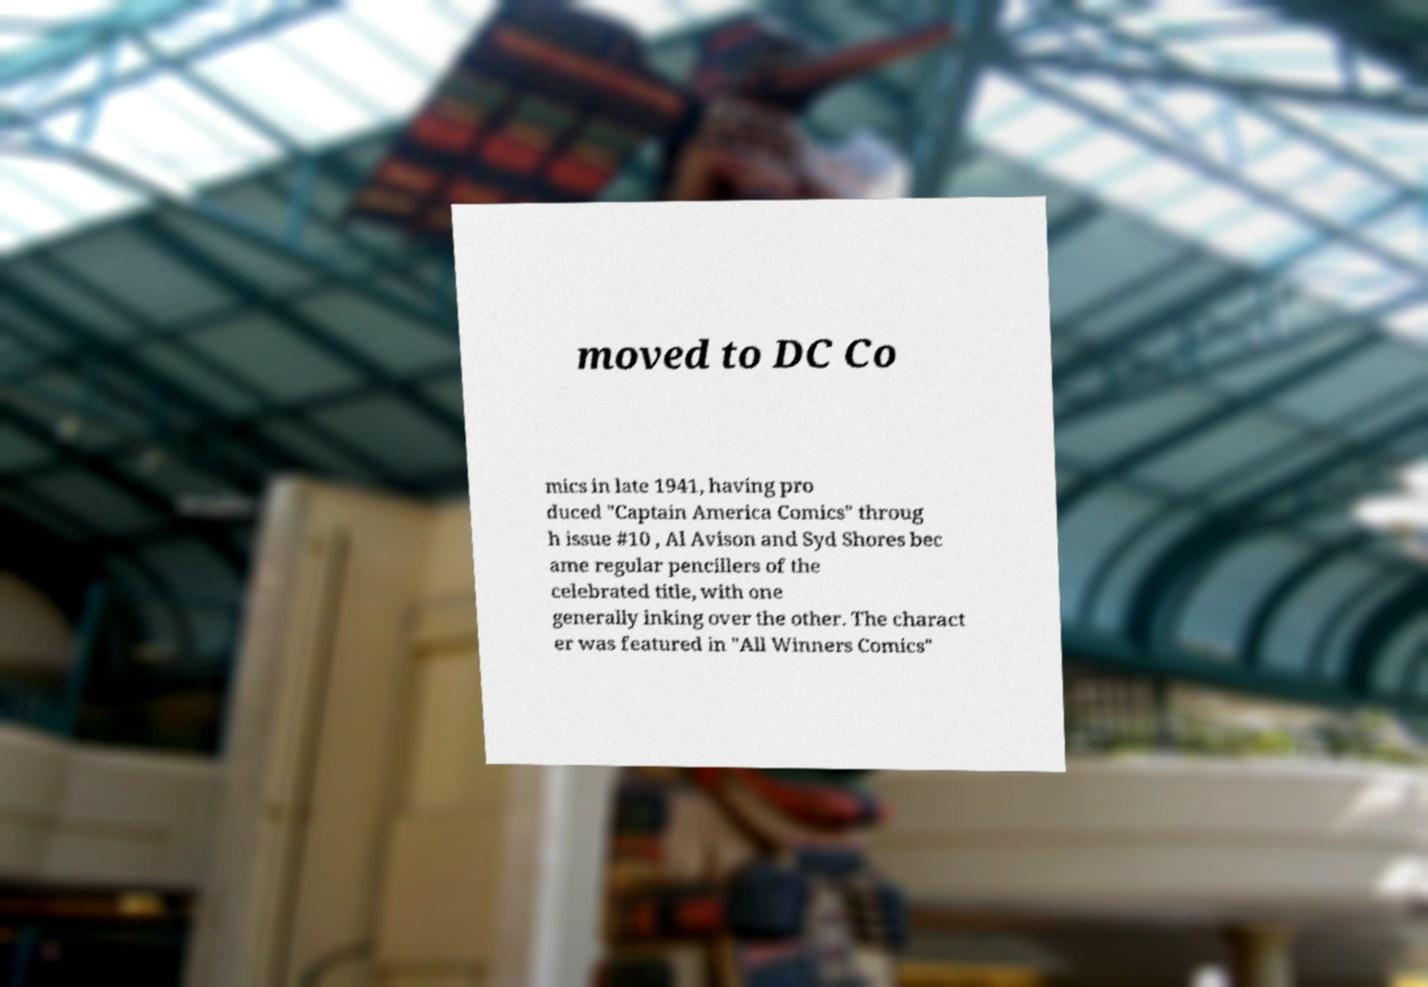There's text embedded in this image that I need extracted. Can you transcribe it verbatim? moved to DC Co mics in late 1941, having pro duced "Captain America Comics" throug h issue #10 , Al Avison and Syd Shores bec ame regular pencillers of the celebrated title, with one generally inking over the other. The charact er was featured in "All Winners Comics" 